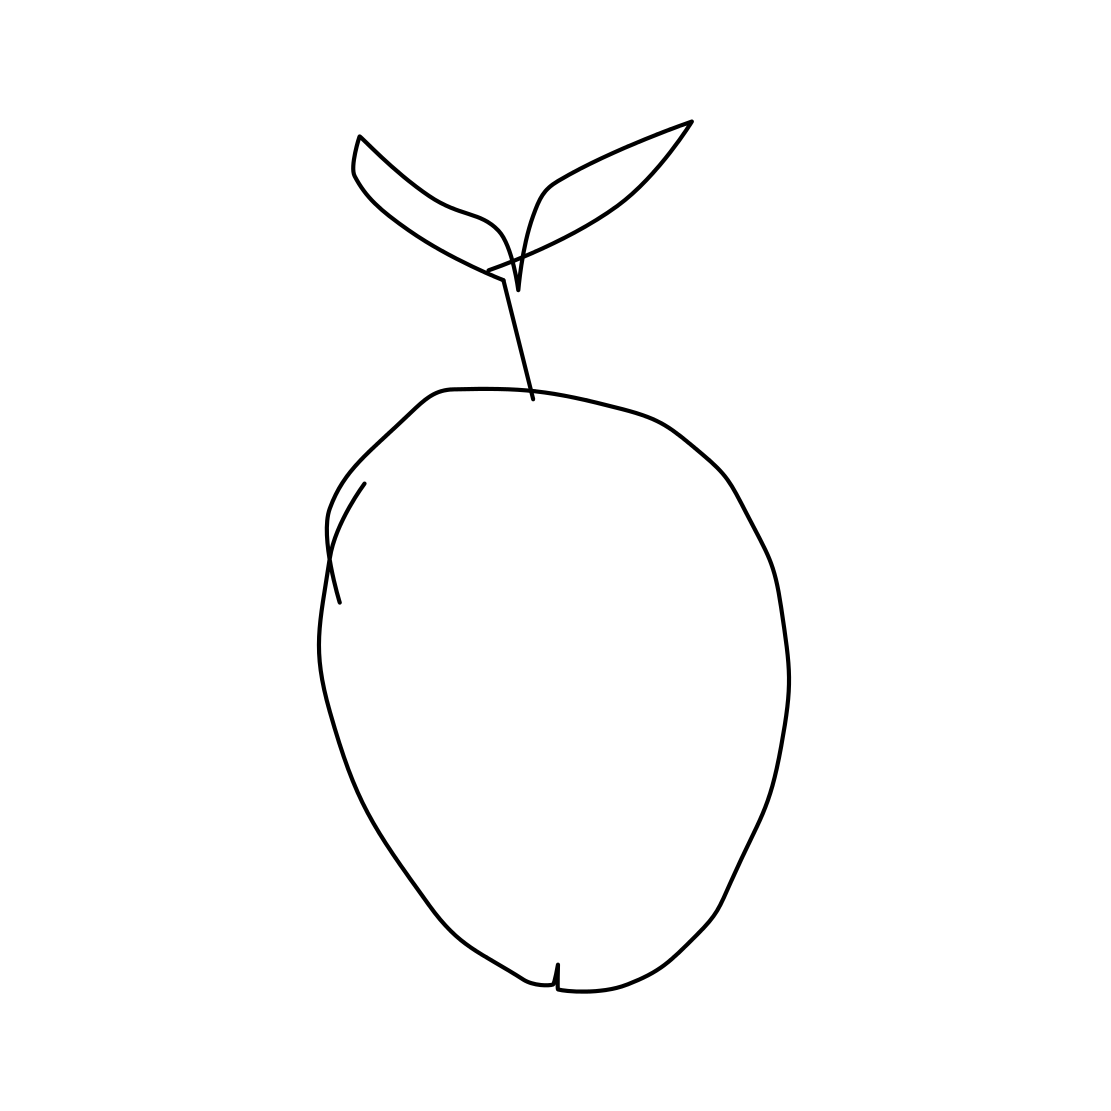Is this image suitable for use as an educational tool to teach children about fruits? Yes, this image could be quite effective as an educational tool for children. Its simplicity and clarity make it easy for young learners to recognize and understand the basic form of an apple. 